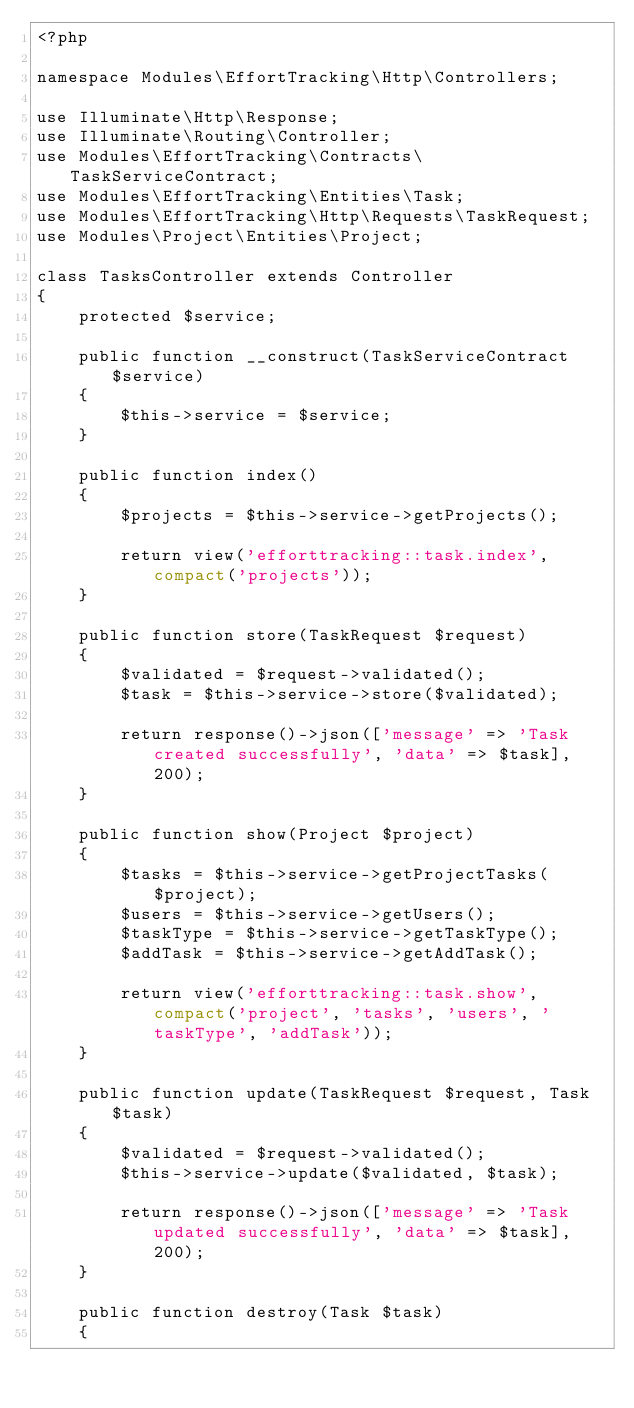Convert code to text. <code><loc_0><loc_0><loc_500><loc_500><_PHP_><?php

namespace Modules\EffortTracking\Http\Controllers;

use Illuminate\Http\Response;
use Illuminate\Routing\Controller;
use Modules\EffortTracking\Contracts\TaskServiceContract;
use Modules\EffortTracking\Entities\Task;
use Modules\EffortTracking\Http\Requests\TaskRequest;
use Modules\Project\Entities\Project;

class TasksController extends Controller
{
    protected $service;

    public function __construct(TaskServiceContract $service)
    {
        $this->service = $service;
    }

    public function index()
    {
        $projects = $this->service->getProjects();

        return view('efforttracking::task.index', compact('projects'));
    }

    public function store(TaskRequest $request)
    {
        $validated = $request->validated();
        $task = $this->service->store($validated);

        return response()->json(['message' => 'Task created successfully', 'data' => $task], 200);
    }

    public function show(Project $project)
    {
        $tasks = $this->service->getProjectTasks($project);
        $users = $this->service->getUsers();
        $taskType = $this->service->getTaskType();
        $addTask = $this->service->getAddTask();

        return view('efforttracking::task.show', compact('project', 'tasks', 'users', 'taskType', 'addTask'));
    }

    public function update(TaskRequest $request, Task $task)
    {
        $validated = $request->validated();
        $this->service->update($validated, $task);

        return response()->json(['message' => 'Task updated successfully', 'data' => $task], 200);
    }

    public function destroy(Task $task)
    {</code> 